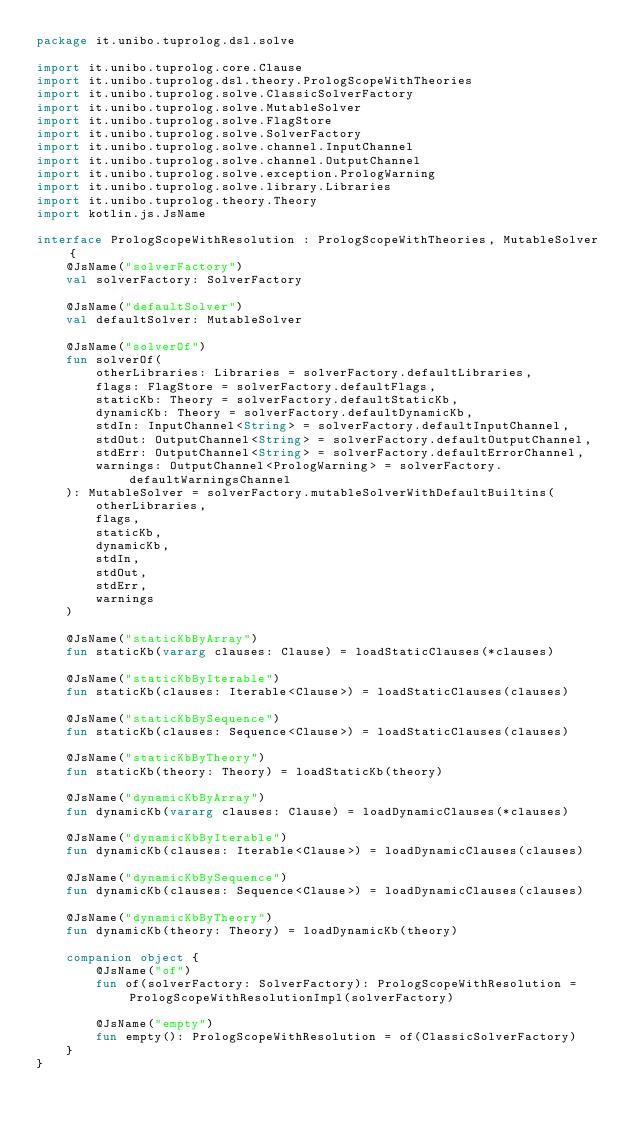<code> <loc_0><loc_0><loc_500><loc_500><_Kotlin_>package it.unibo.tuprolog.dsl.solve

import it.unibo.tuprolog.core.Clause
import it.unibo.tuprolog.dsl.theory.PrologScopeWithTheories
import it.unibo.tuprolog.solve.ClassicSolverFactory
import it.unibo.tuprolog.solve.MutableSolver
import it.unibo.tuprolog.solve.FlagStore
import it.unibo.tuprolog.solve.SolverFactory
import it.unibo.tuprolog.solve.channel.InputChannel
import it.unibo.tuprolog.solve.channel.OutputChannel
import it.unibo.tuprolog.solve.exception.PrologWarning
import it.unibo.tuprolog.solve.library.Libraries
import it.unibo.tuprolog.theory.Theory
import kotlin.js.JsName

interface PrologScopeWithResolution : PrologScopeWithTheories, MutableSolver {
    @JsName("solverFactory")
    val solverFactory: SolverFactory

    @JsName("defaultSolver")
    val defaultSolver: MutableSolver

    @JsName("solverOf")
    fun solverOf(
        otherLibraries: Libraries = solverFactory.defaultLibraries,
        flags: FlagStore = solverFactory.defaultFlags,
        staticKb: Theory = solverFactory.defaultStaticKb,
        dynamicKb: Theory = solverFactory.defaultDynamicKb,
        stdIn: InputChannel<String> = solverFactory.defaultInputChannel,
        stdOut: OutputChannel<String> = solverFactory.defaultOutputChannel,
        stdErr: OutputChannel<String> = solverFactory.defaultErrorChannel,
        warnings: OutputChannel<PrologWarning> = solverFactory.defaultWarningsChannel
    ): MutableSolver = solverFactory.mutableSolverWithDefaultBuiltins(
        otherLibraries,
        flags,
        staticKb,
        dynamicKb,
        stdIn,
        stdOut,
        stdErr,
        warnings
    )

    @JsName("staticKbByArray")
    fun staticKb(vararg clauses: Clause) = loadStaticClauses(*clauses)

    @JsName("staticKbByIterable")
    fun staticKb(clauses: Iterable<Clause>) = loadStaticClauses(clauses)

    @JsName("staticKbBySequence")
    fun staticKb(clauses: Sequence<Clause>) = loadStaticClauses(clauses)

    @JsName("staticKbByTheory")
    fun staticKb(theory: Theory) = loadStaticKb(theory)

    @JsName("dynamicKbByArray")
    fun dynamicKb(vararg clauses: Clause) = loadDynamicClauses(*clauses)

    @JsName("dynamicKbByIterable")
    fun dynamicKb(clauses: Iterable<Clause>) = loadDynamicClauses(clauses)

    @JsName("dynamicKbBySequence")
    fun dynamicKb(clauses: Sequence<Clause>) = loadDynamicClauses(clauses)

    @JsName("dynamicKbByTheory")
    fun dynamicKb(theory: Theory) = loadDynamicKb(theory)

    companion object {
        @JsName("of")
        fun of(solverFactory: SolverFactory): PrologScopeWithResolution = PrologScopeWithResolutionImpl(solverFactory)

        @JsName("empty")
        fun empty(): PrologScopeWithResolution = of(ClassicSolverFactory)
    }
}</code> 